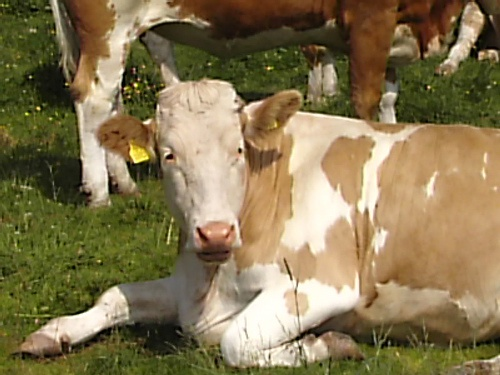Describe the objects in this image and their specific colors. I can see cow in darkgreen, tan, and ivory tones, cow in darkgreen, black, maroon, and tan tones, and cow in darkgreen, black, tan, and gray tones in this image. 